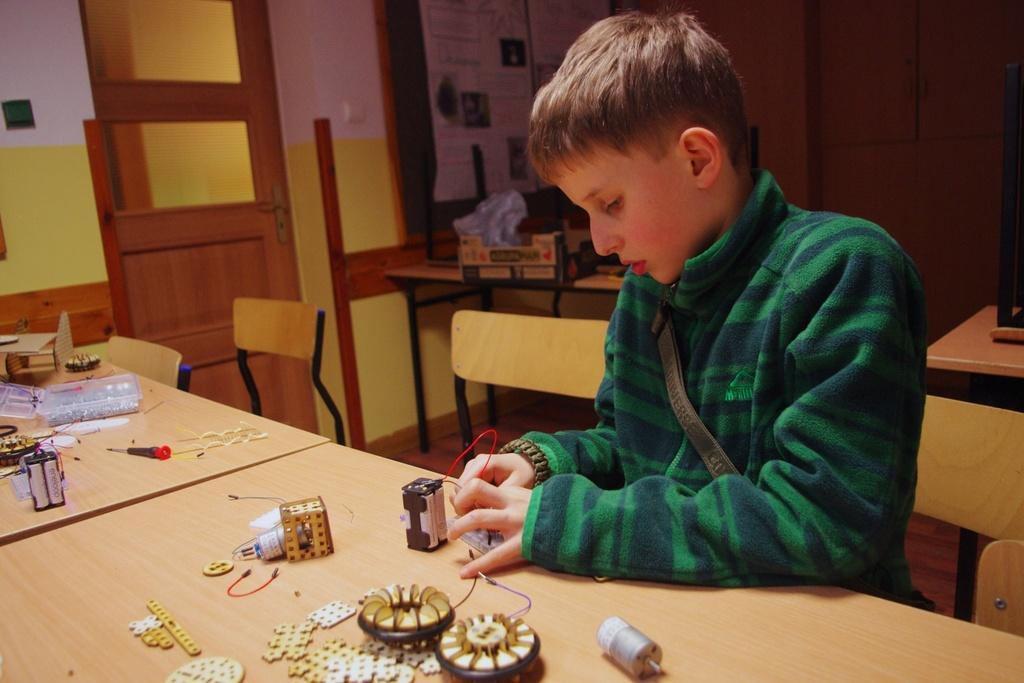Can you describe this image briefly? In this image i can see a person sitting on chair and doing something on table at the back ground i can see adoor. 